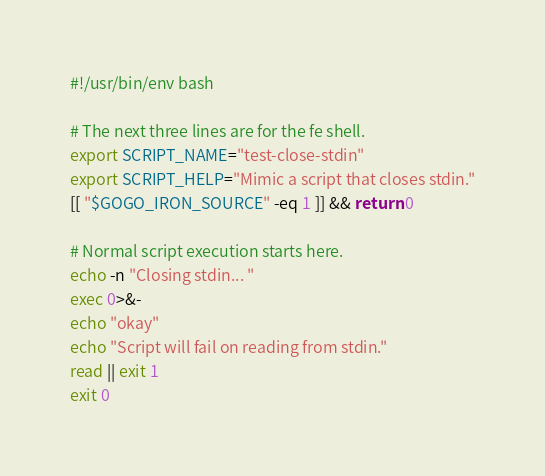<code> <loc_0><loc_0><loc_500><loc_500><_Bash_>#!/usr/bin/env bash

# The next three lines are for the fe shell.
export SCRIPT_NAME="test-close-stdin"
export SCRIPT_HELP="Mimic a script that closes stdin."
[[ "$GOGO_IRON_SOURCE" -eq 1 ]] && return 0

# Normal script execution starts here.
echo -n "Closing stdin... "
exec 0>&-
echo "okay"
echo "Script will fail on reading from stdin."
read || exit 1
exit 0

</code> 